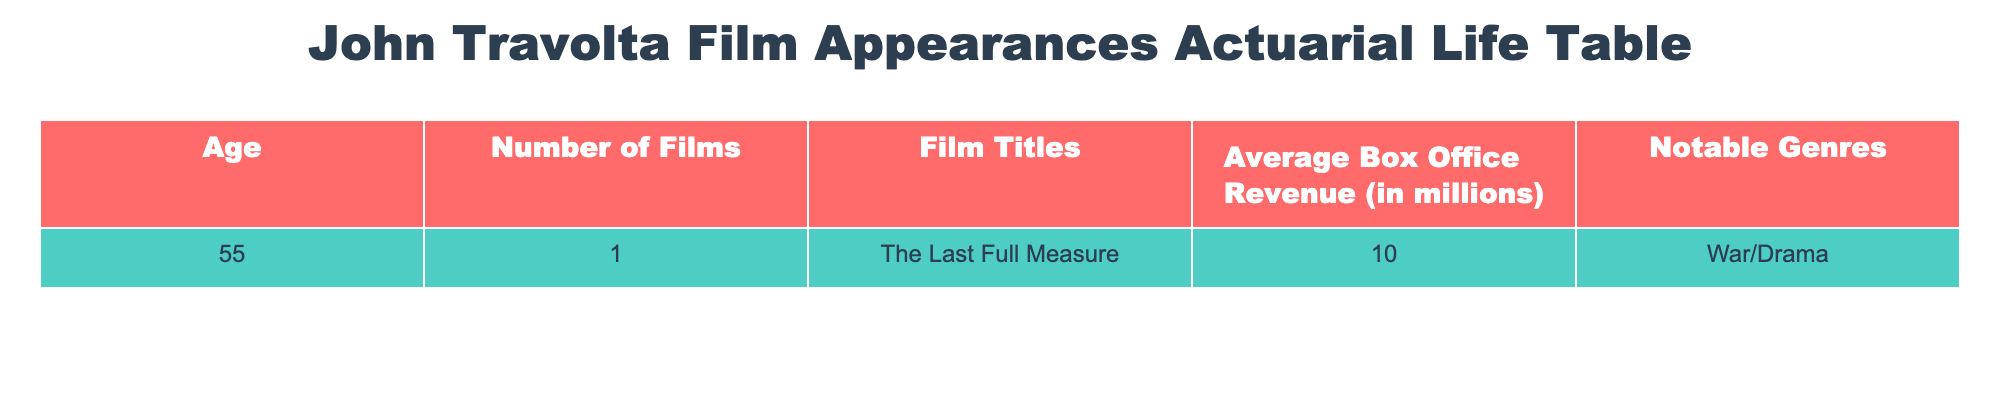What is the total number of films John Travolta appeared in at age 55? The table indicates that John Travolta had 1 film appearance at age 55. Therefore, the total number of films is simply the number listed under the "Number of Films" column at that age.
Answer: 1 What is the title of the film John Travolta appeared in when he was 55? According to the table, the "Film Titles" column shows the film "The Last Full Measure" for age 55. Thus, this is the title of the film.
Answer: The Last Full Measure What is the average box office revenue of John Travolta's film at age 55? The table presents the average box office revenue of 10 million in the "Average Box Office Revenue" column for age 55. Therefore, this is the stated average for that age.
Answer: 10 million Is "The Last Full Measure" a film in the War/Drama genre? The table indicates that the notable genre for "The Last Full Measure" is listed as War/Drama, confirming that this film indeed belongs to that genre.
Answer: Yes At age 55, how does the average box office revenue compare to the number of films released? The average box office revenue is 10 million, and the number of films released is 1. Since we have both values, the revenue per film can be calculated as 10 million/1, which shows the average revenue per film directly corresponds to the total revenue since there is only one film.
Answer: The average revenue is 10 million per film What is the difference between the average box office revenue and the number of films? The average box office revenue is 10 million, while the number of films is 1. To find the difference, we can treat the number of films as 1 million for comparison. The difference is 10 million - 1 million = 9 million.
Answer: 9 million If John Travolta were to release 2 more films with the same average box office revenue, what would be the total box office revenue? Currently, he has 1 film with an average box office revenue of 10 million. If he adds 2 more films of the same average revenue, the total becomes 3 films. Hence, the total box office revenue is 3 films x 10 million = 30 million.
Answer: 30 million How many notable genres are listed for the film at age 55? The table states one notable genre, "War/Drama," for the film "The Last Full Measure." Therefore, only one genre is identified for this film at that age.
Answer: 1 